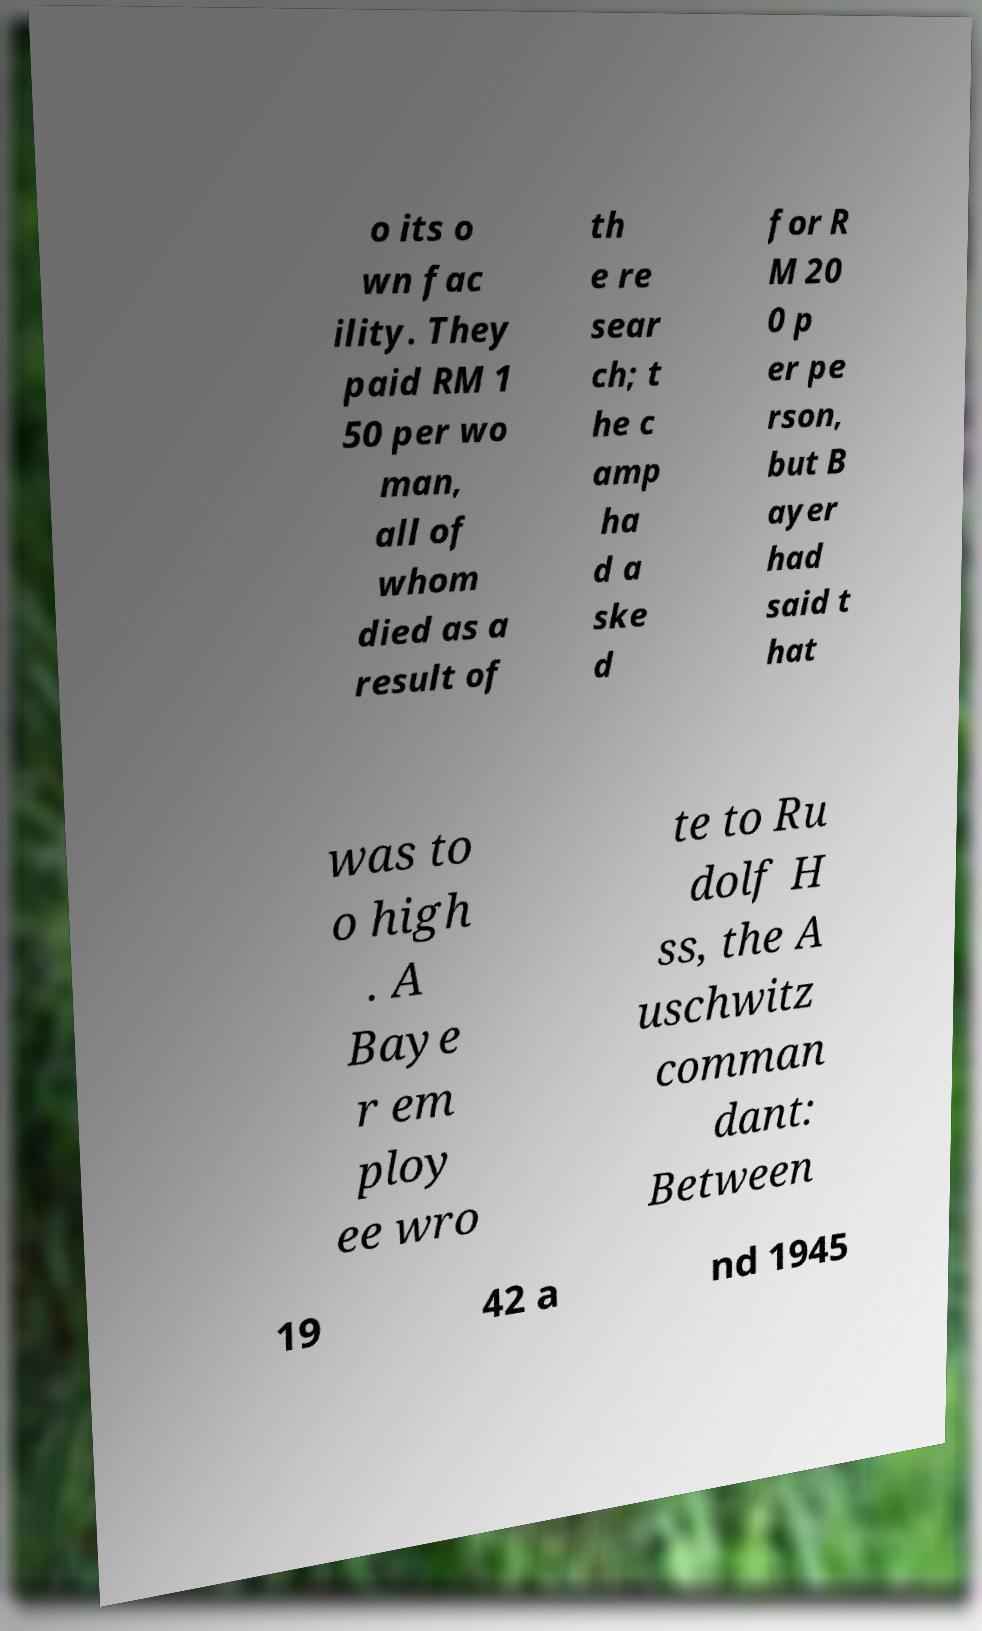There's text embedded in this image that I need extracted. Can you transcribe it verbatim? o its o wn fac ility. They paid RM 1 50 per wo man, all of whom died as a result of th e re sear ch; t he c amp ha d a ske d for R M 20 0 p er pe rson, but B ayer had said t hat was to o high . A Baye r em ploy ee wro te to Ru dolf H ss, the A uschwitz comman dant: Between 19 42 a nd 1945 